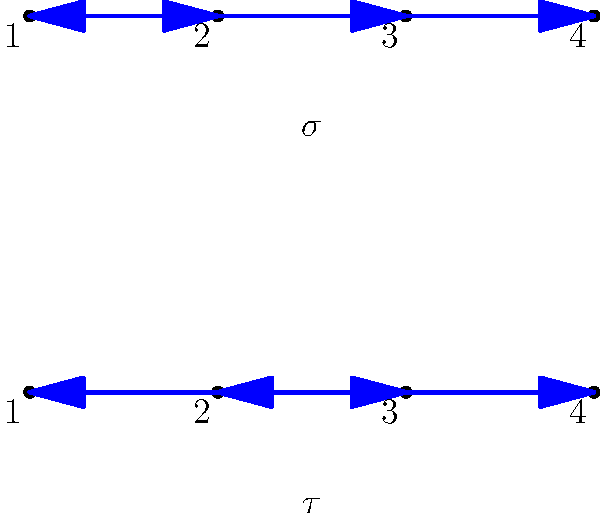In the context of group theory, consider the two permutations $\sigma$ and $\tau$ represented by the arrow diagrams above. What is the cycle notation of the composition $\sigma \circ \tau$? How might this concept be used to create an engaging activity for children to understand the impact of parental incarceration on family dynamics? Let's approach this step-by-step:

1) First, we need to understand what each permutation does:
   $\sigma: (1 \rightarrow 2 \rightarrow 3 \rightarrow 4 \rightarrow 1)$
   $\tau: (1 \rightarrow 3 \rightarrow 2 \rightarrow 4 \rightarrow 1)$

2) To compose $\sigma \circ \tau$, we apply $\tau$ first, then $\sigma$:
   
   1 $\xrightarrow{\tau}$ 3 $\xrightarrow{\sigma}$ 4
   2 $\xrightarrow{\tau}$ 4 $\xrightarrow{\sigma}$ 1
   3 $\xrightarrow{\tau}$ 2 $\xrightarrow{\sigma}$ 3
   4 $\xrightarrow{\tau}$ 1 $\xrightarrow{\sigma}$ 2

3) From this, we can write the cycle notation:
   $\sigma \circ \tau = (1 4 2)(3)$

4) For the educational context:
   This concept could be used to create an activity where children explore how family roles and responsibilities shift when a parent is incarcerated. Each number could represent a family member or a family responsibility. The permutations could represent how these roles change when a parent is absent and then when they return. This helps children visualize and understand the dynamic nature of family structures and responsibilities in challenging situations.
Answer: $(1 4 2)(3)$ 